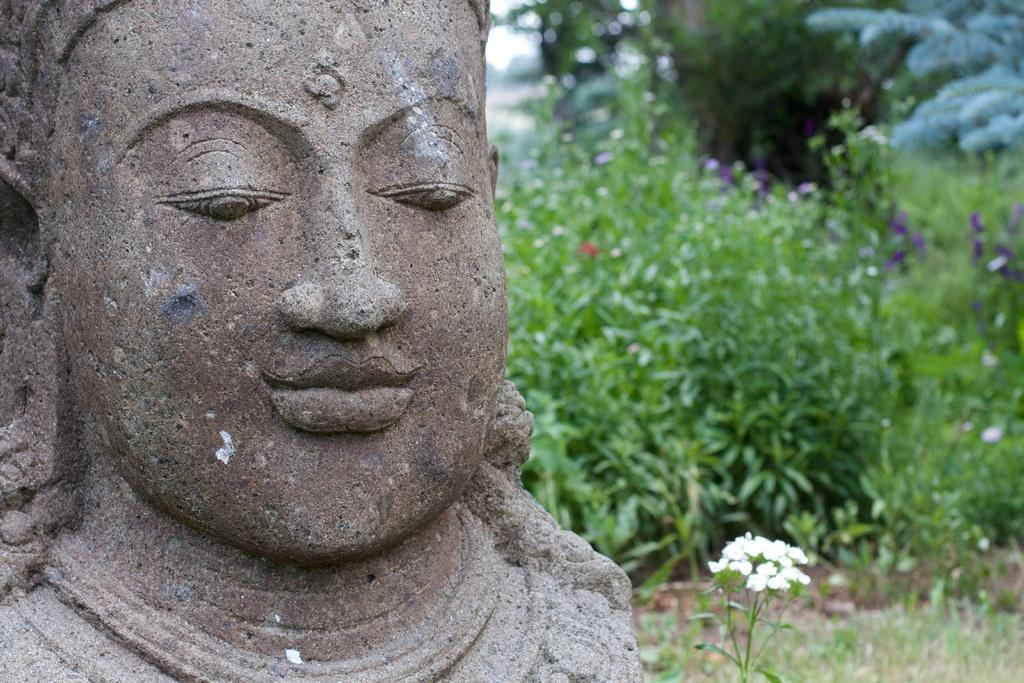What is located on the left side of the image? There is a statue of a person on the left side of the image. What is near the statue? There are flowers beside the statue. What can be seen behind the statue? There are plants with flowers behind the statue. What type of machine is being used to commit a crime in the image? There is no machine or crime present in the image; it features a statue with flowers beside and behind it. 